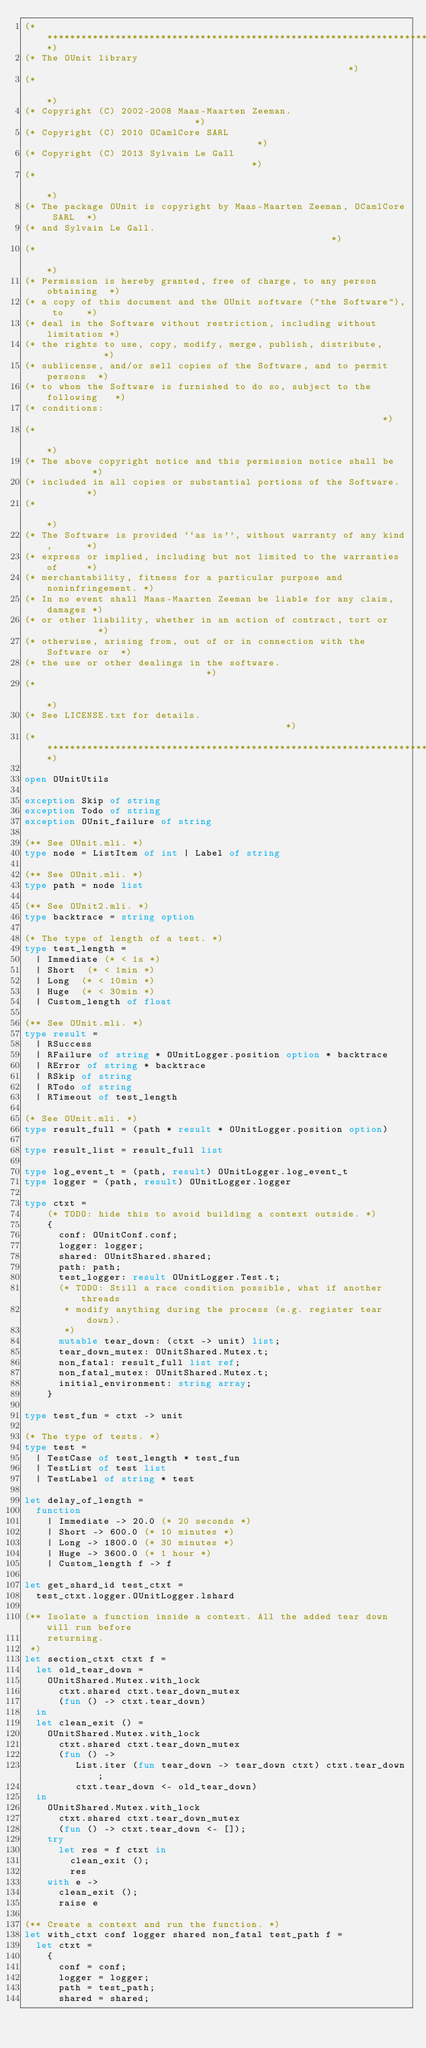<code> <loc_0><loc_0><loc_500><loc_500><_OCaml_>(**************************************************************************)
(* The OUnit library                                                      *)
(*                                                                        *)
(* Copyright (C) 2002-2008 Maas-Maarten Zeeman.                           *)
(* Copyright (C) 2010 OCamlCore SARL                                      *)
(* Copyright (C) 2013 Sylvain Le Gall                                     *)
(*                                                                        *)
(* The package OUnit is copyright by Maas-Maarten Zeeman, OCamlCore SARL  *)
(* and Sylvain Le Gall.                                                   *)
(*                                                                        *)
(* Permission is hereby granted, free of charge, to any person obtaining  *)
(* a copy of this document and the OUnit software ("the Software"), to    *)
(* deal in the Software without restriction, including without limitation *)
(* the rights to use, copy, modify, merge, publish, distribute,           *)
(* sublicense, and/or sell copies of the Software, and to permit persons  *)
(* to whom the Software is furnished to do so, subject to the following   *)
(* conditions:                                                            *)
(*                                                                        *)
(* The above copyright notice and this permission notice shall be         *)
(* included in all copies or substantial portions of the Software.        *)
(*                                                                        *)
(* The Software is provided ``as is'', without warranty of any kind,      *)
(* express or implied, including but not limited to the warranties of     *)
(* merchantability, fitness for a particular purpose and noninfringement. *)
(* In no event shall Maas-Maarten Zeeman be liable for any claim, damages *)
(* or other liability, whether in an action of contract, tort or          *)
(* otherwise, arising from, out of or in connection with the Software or  *)
(* the use or other dealings in the software.                             *)
(*                                                                        *)
(* See LICENSE.txt for details.                                           *)
(**************************************************************************)

open OUnitUtils

exception Skip of string
exception Todo of string
exception OUnit_failure of string

(** See OUnit.mli. *)
type node = ListItem of int | Label of string

(** See OUnit.mli. *)
type path = node list

(** See OUnit2.mli. *)
type backtrace = string option

(* The type of length of a test. *)
type test_length =
  | Immediate (* < 1s *)
  | Short  (* < 1min *)
  | Long  (* < 10min *)
  | Huge  (* < 30min *)
  | Custom_length of float

(** See OUnit.mli. *)
type result =
  | RSuccess
  | RFailure of string * OUnitLogger.position option * backtrace
  | RError of string * backtrace
  | RSkip of string
  | RTodo of string
  | RTimeout of test_length

(* See OUnit.mli. *)
type result_full = (path * result * OUnitLogger.position option)

type result_list = result_full list

type log_event_t = (path, result) OUnitLogger.log_event_t
type logger = (path, result) OUnitLogger.logger

type ctxt =
    (* TODO: hide this to avoid building a context outside. *)
    {
      conf: OUnitConf.conf;
      logger: logger;
      shared: OUnitShared.shared;
      path: path;
      test_logger: result OUnitLogger.Test.t;
      (* TODO: Still a race condition possible, what if another threads
       * modify anything during the process (e.g. register tear down).
       *)
      mutable tear_down: (ctxt -> unit) list;
      tear_down_mutex: OUnitShared.Mutex.t;
      non_fatal: result_full list ref;
      non_fatal_mutex: OUnitShared.Mutex.t;
      initial_environment: string array;
    }

type test_fun = ctxt -> unit

(* The type of tests. *)
type test =
  | TestCase of test_length * test_fun
  | TestList of test list
  | TestLabel of string * test

let delay_of_length =
  function
    | Immediate -> 20.0 (* 20 seconds *)
    | Short -> 600.0 (* 10 minutes *)
    | Long -> 1800.0 (* 30 minutes *)
    | Huge -> 3600.0 (* 1 hour *)
    | Custom_length f -> f

let get_shard_id test_ctxt =
  test_ctxt.logger.OUnitLogger.lshard

(** Isolate a function inside a context. All the added tear down will run before
    returning.
 *)
let section_ctxt ctxt f =
  let old_tear_down =
    OUnitShared.Mutex.with_lock
      ctxt.shared ctxt.tear_down_mutex
      (fun () -> ctxt.tear_down)
  in
  let clean_exit () =
    OUnitShared.Mutex.with_lock
      ctxt.shared ctxt.tear_down_mutex
      (fun () ->
         List.iter (fun tear_down -> tear_down ctxt) ctxt.tear_down;
         ctxt.tear_down <- old_tear_down)
  in
    OUnitShared.Mutex.with_lock
      ctxt.shared ctxt.tear_down_mutex
      (fun () -> ctxt.tear_down <- []);
    try
      let res = f ctxt in
        clean_exit ();
        res
    with e ->
      clean_exit ();
      raise e

(** Create a context and run the function. *)
let with_ctxt conf logger shared non_fatal test_path f =
  let ctxt =
    {
      conf = conf;
      logger = logger;
      path = test_path;
      shared = shared;</code> 